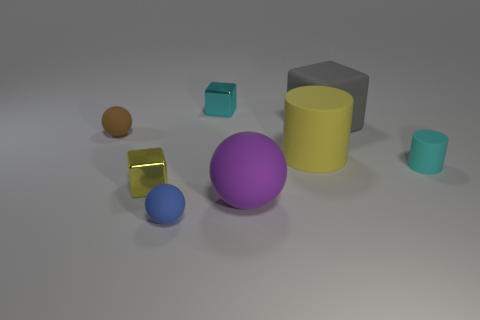How many small brown rubber objects are on the left side of the tiny blue matte object left of the small matte object on the right side of the cyan metal cube?
Your answer should be compact. 1. Is the number of cyan blocks that are in front of the small yellow metallic thing less than the number of large gray rubber blocks?
Ensure brevity in your answer.  Yes. The tiny cyan metal object to the right of the blue object has what shape?
Keep it short and to the point. Cube. There is a tiny cyan thing on the right side of the cyan object left of the cyan thing to the right of the purple matte thing; what is its shape?
Your answer should be compact. Cylinder. What number of things are either green cylinders or tiny rubber balls?
Offer a very short reply. 2. There is a metal object behind the big gray thing; does it have the same shape as the small object on the right side of the yellow rubber cylinder?
Offer a very short reply. No. What number of rubber objects are on the left side of the small blue thing and on the right side of the purple matte thing?
Offer a very short reply. 0. What number of other objects are there of the same size as the cyan cube?
Offer a very short reply. 4. There is a tiny object that is both behind the large rubber cylinder and left of the small blue matte thing; what is it made of?
Provide a short and direct response. Rubber. There is a large cylinder; does it have the same color as the small cube that is on the left side of the blue matte thing?
Give a very brief answer. Yes. 